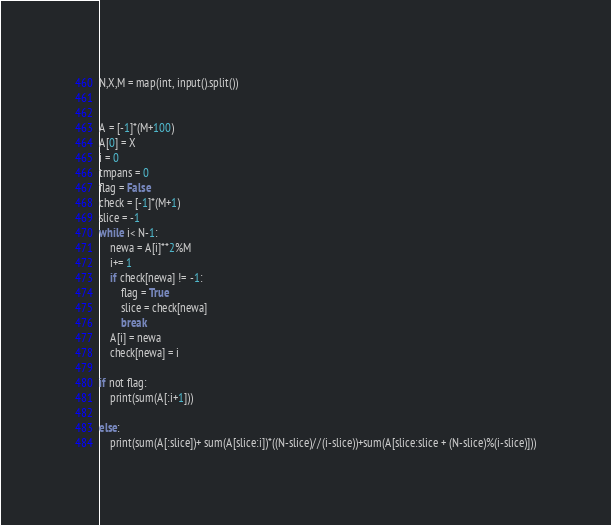<code> <loc_0><loc_0><loc_500><loc_500><_Python_>N,X,M = map(int, input().split())


A = [-1]*(M+100)
A[0] = X
i = 0
tmpans = 0
flag = False
check = [-1]*(M+1)
slice = -1
while i< N-1:
    newa = A[i]**2%M
    i+= 1
    if check[newa] != -1:
        flag = True
        slice = check[newa]
        break
    A[i] = newa
    check[newa] = i

if not flag:
    print(sum(A[:i+1]))

else:
    print(sum(A[:slice])+ sum(A[slice:i])*((N-slice)//(i-slice))+sum(A[slice:slice + (N-slice)%(i-slice)]))
</code> 